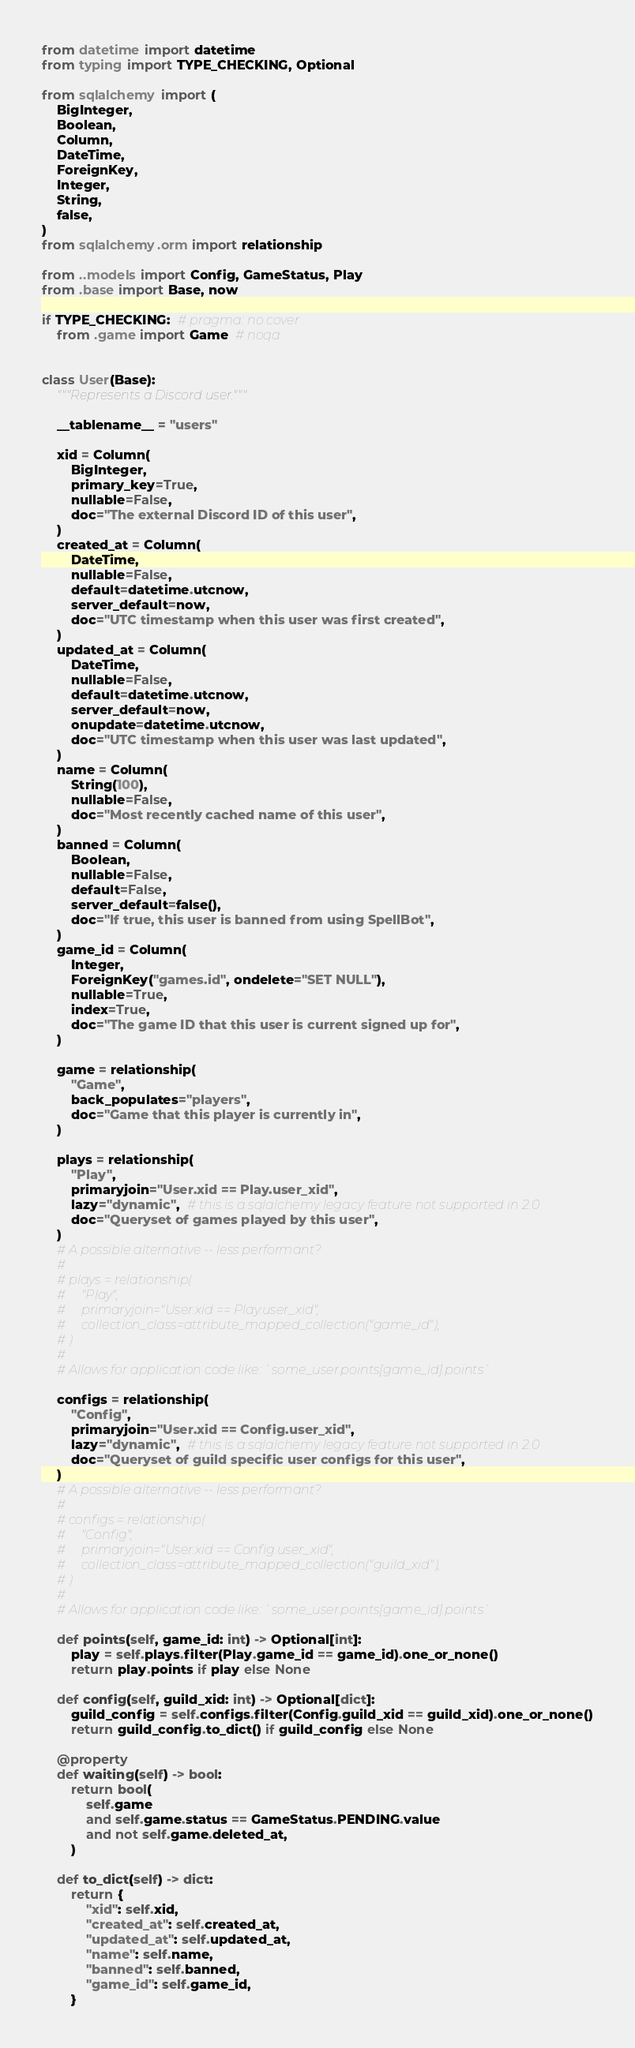Convert code to text. <code><loc_0><loc_0><loc_500><loc_500><_Python_>from datetime import datetime
from typing import TYPE_CHECKING, Optional

from sqlalchemy import (
    BigInteger,
    Boolean,
    Column,
    DateTime,
    ForeignKey,
    Integer,
    String,
    false,
)
from sqlalchemy.orm import relationship

from ..models import Config, GameStatus, Play
from .base import Base, now

if TYPE_CHECKING:  # pragma: no cover
    from .game import Game  # noqa


class User(Base):
    """Represents a Discord user."""

    __tablename__ = "users"

    xid = Column(
        BigInteger,
        primary_key=True,
        nullable=False,
        doc="The external Discord ID of this user",
    )
    created_at = Column(
        DateTime,
        nullable=False,
        default=datetime.utcnow,
        server_default=now,
        doc="UTC timestamp when this user was first created",
    )
    updated_at = Column(
        DateTime,
        nullable=False,
        default=datetime.utcnow,
        server_default=now,
        onupdate=datetime.utcnow,
        doc="UTC timestamp when this user was last updated",
    )
    name = Column(
        String(100),
        nullable=False,
        doc="Most recently cached name of this user",
    )
    banned = Column(
        Boolean,
        nullable=False,
        default=False,
        server_default=false(),
        doc="If true, this user is banned from using SpellBot",
    )
    game_id = Column(
        Integer,
        ForeignKey("games.id", ondelete="SET NULL"),
        nullable=True,
        index=True,
        doc="The game ID that this user is current signed up for",
    )

    game = relationship(
        "Game",
        back_populates="players",
        doc="Game that this player is currently in",
    )

    plays = relationship(
        "Play",
        primaryjoin="User.xid == Play.user_xid",
        lazy="dynamic",  # this is a sqlalchemy legacy feature not supported in 2.0
        doc="Queryset of games played by this user",
    )
    # A possible alternative -- less performant?
    #
    # plays = relationship(
    #     "Play",
    #     primaryjoin="User.xid == Play.user_xid",
    #     collection_class=attribute_mapped_collection("game_id"),
    # )
    #
    # Allows for application code like: `some_user.points[game_id].points`

    configs = relationship(
        "Config",
        primaryjoin="User.xid == Config.user_xid",
        lazy="dynamic",  # this is a sqlalchemy legacy feature not supported in 2.0
        doc="Queryset of guild specific user configs for this user",
    )
    # A possible alternative -- less performant?
    #
    # configs = relationship(
    #     "Config",
    #     primaryjoin="User.xid == Config.user_xid",
    #     collection_class=attribute_mapped_collection("guild_xid"),
    # )
    #
    # Allows for application code like: `some_user.points[game_id].points`

    def points(self, game_id: int) -> Optional[int]:
        play = self.plays.filter(Play.game_id == game_id).one_or_none()
        return play.points if play else None

    def config(self, guild_xid: int) -> Optional[dict]:
        guild_config = self.configs.filter(Config.guild_xid == guild_xid).one_or_none()
        return guild_config.to_dict() if guild_config else None

    @property
    def waiting(self) -> bool:
        return bool(
            self.game
            and self.game.status == GameStatus.PENDING.value
            and not self.game.deleted_at,
        )

    def to_dict(self) -> dict:
        return {
            "xid": self.xid,
            "created_at": self.created_at,
            "updated_at": self.updated_at,
            "name": self.name,
            "banned": self.banned,
            "game_id": self.game_id,
        }
</code> 